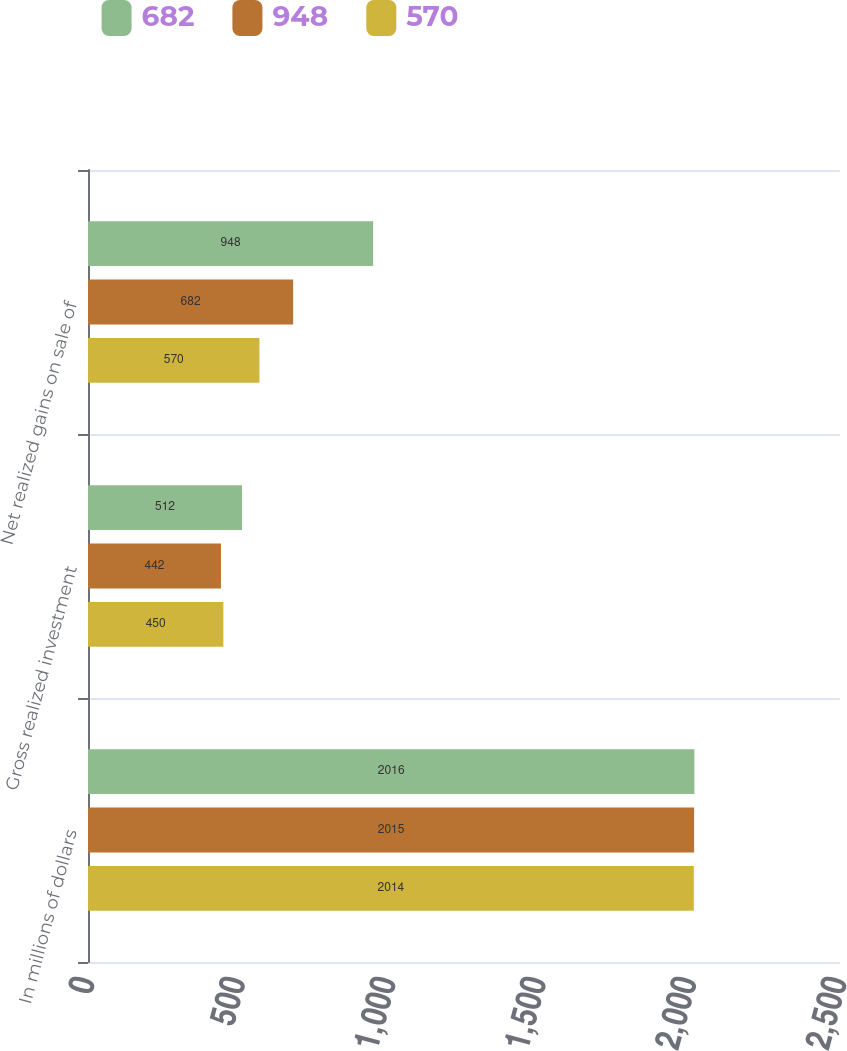Convert chart. <chart><loc_0><loc_0><loc_500><loc_500><stacked_bar_chart><ecel><fcel>In millions of dollars<fcel>Gross realized investment<fcel>Net realized gains on sale of<nl><fcel>682<fcel>2016<fcel>512<fcel>948<nl><fcel>948<fcel>2015<fcel>442<fcel>682<nl><fcel>570<fcel>2014<fcel>450<fcel>570<nl></chart> 